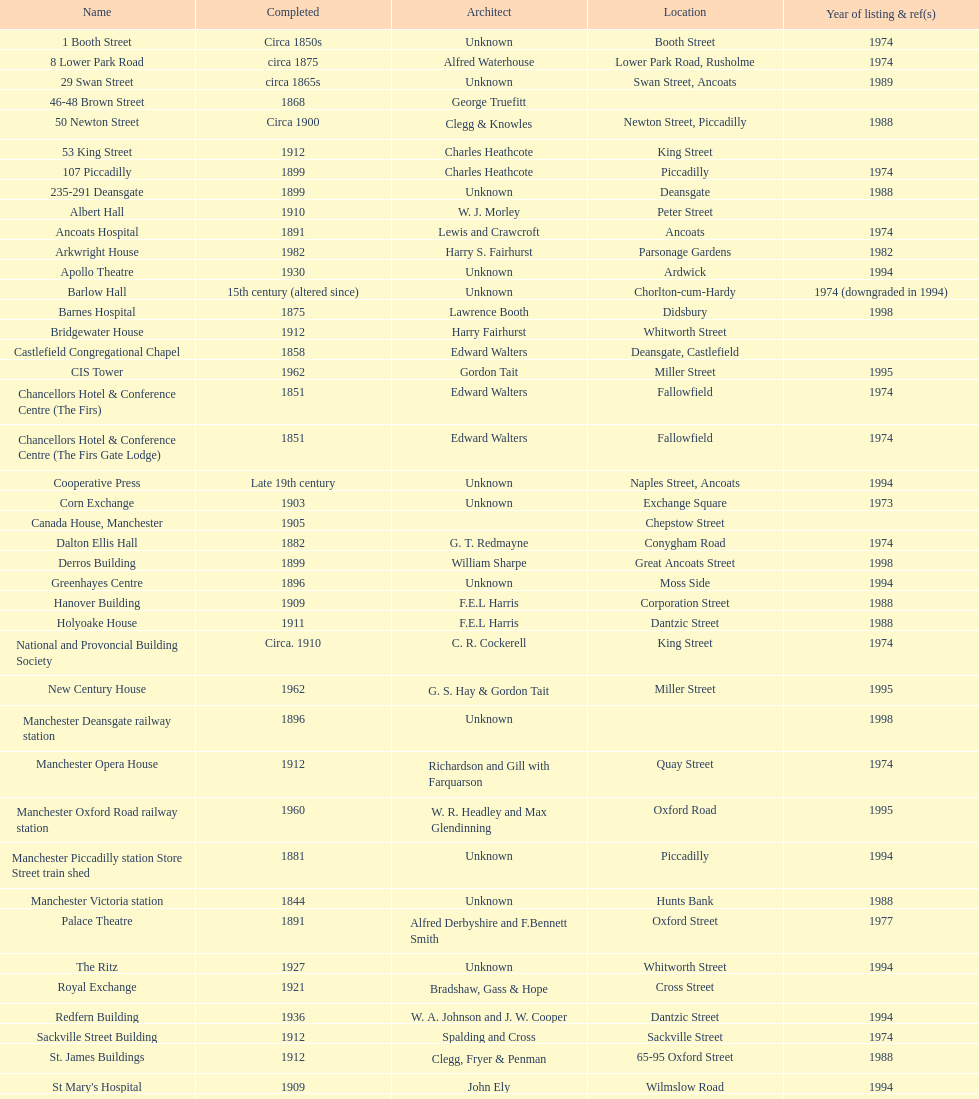Which two buildings were listed before 1974? The Old Wellington Inn, Smithfield Market Hall. 